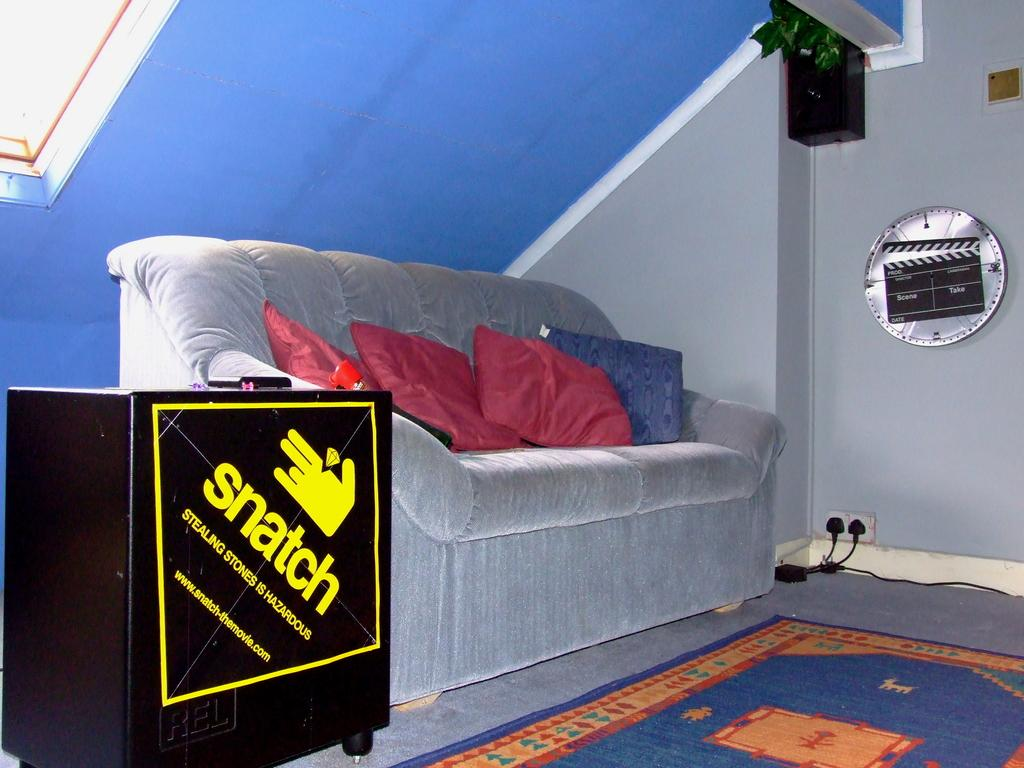Where is the image taken? The image is inside a room. What type of seating is present in the room? There is a sofa in the room. What other furniture can be seen in the room? There is furniture in the room. What is on the floor in the room? There is a mat on the floor. What is on the sofa? There are pillows on the sofa. What can be seen in the background of the room? There is a wall, a ring disk, and a speaker in the background. How many clocks are hanging on the wall in the image? There are no clocks visible in the image. What type of division is taking place in the room? There is no division taking place in the room; the image simply shows a room with various objects. 